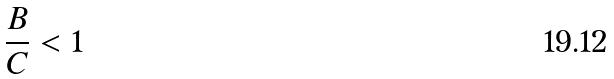<formula> <loc_0><loc_0><loc_500><loc_500>\frac { B } { C } < 1</formula> 